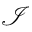Convert formula to latex. <formula><loc_0><loc_0><loc_500><loc_500>\mathcal { I }</formula> 